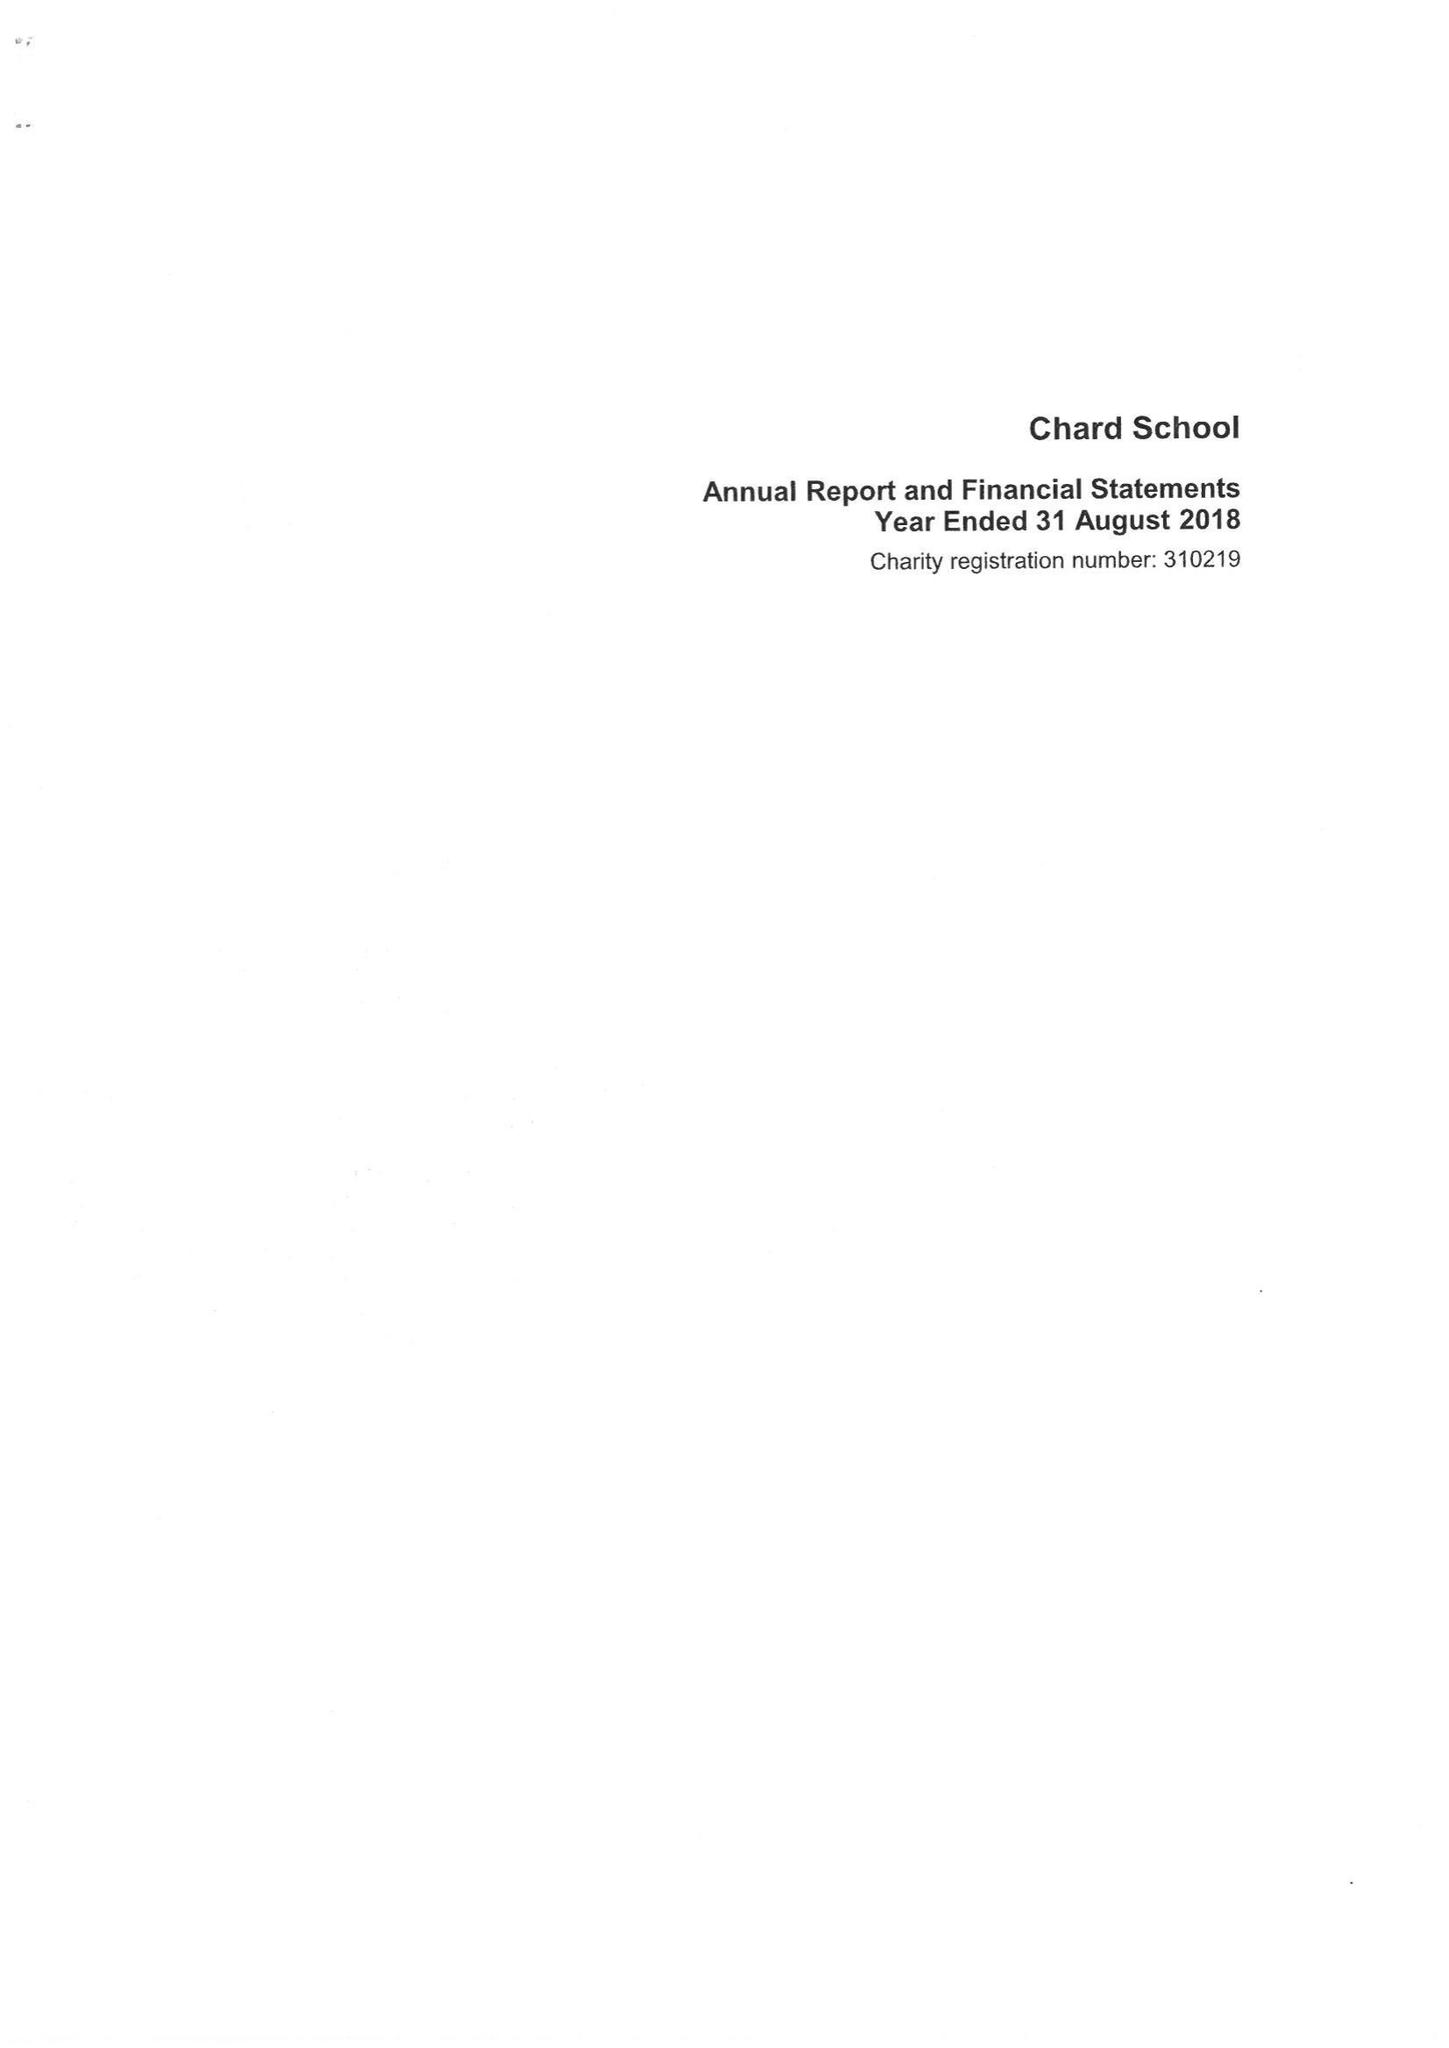What is the value for the charity_number?
Answer the question using a single word or phrase. 310219 